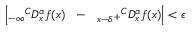Convert formula to latex. <formula><loc_0><loc_0><loc_500><loc_500>\left | _ { - \infty ^ { C } D _ { x } ^ { \alpha } f ( x ) _ { x - \delta ^ { + } ^ { C } D _ { x } ^ { \alpha } f ( x ) \right | < \epsilon</formula> 